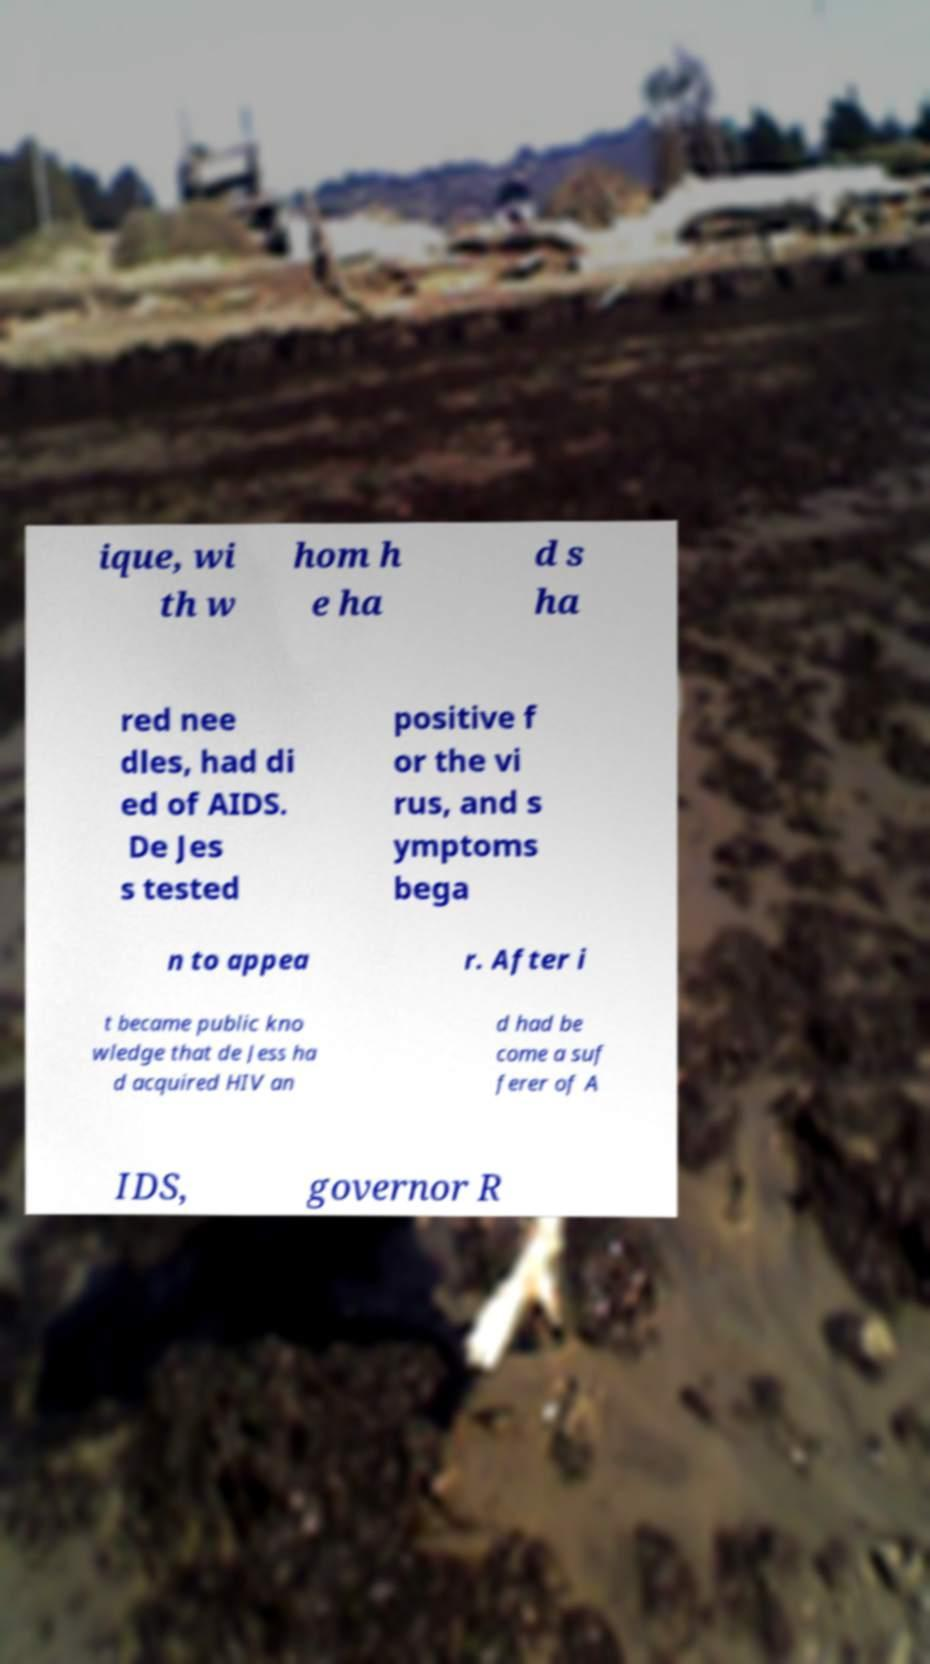Can you read and provide the text displayed in the image?This photo seems to have some interesting text. Can you extract and type it out for me? ique, wi th w hom h e ha d s ha red nee dles, had di ed of AIDS. De Jes s tested positive f or the vi rus, and s ymptoms bega n to appea r. After i t became public kno wledge that de Jess ha d acquired HIV an d had be come a suf ferer of A IDS, governor R 